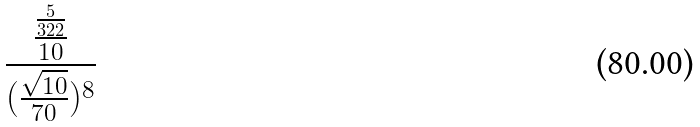Convert formula to latex. <formula><loc_0><loc_0><loc_500><loc_500>\frac { \frac { \frac { 5 } { 3 2 2 } } { 1 0 } } { ( \frac { \sqrt { 1 0 } } { 7 0 } ) ^ { 8 } }</formula> 